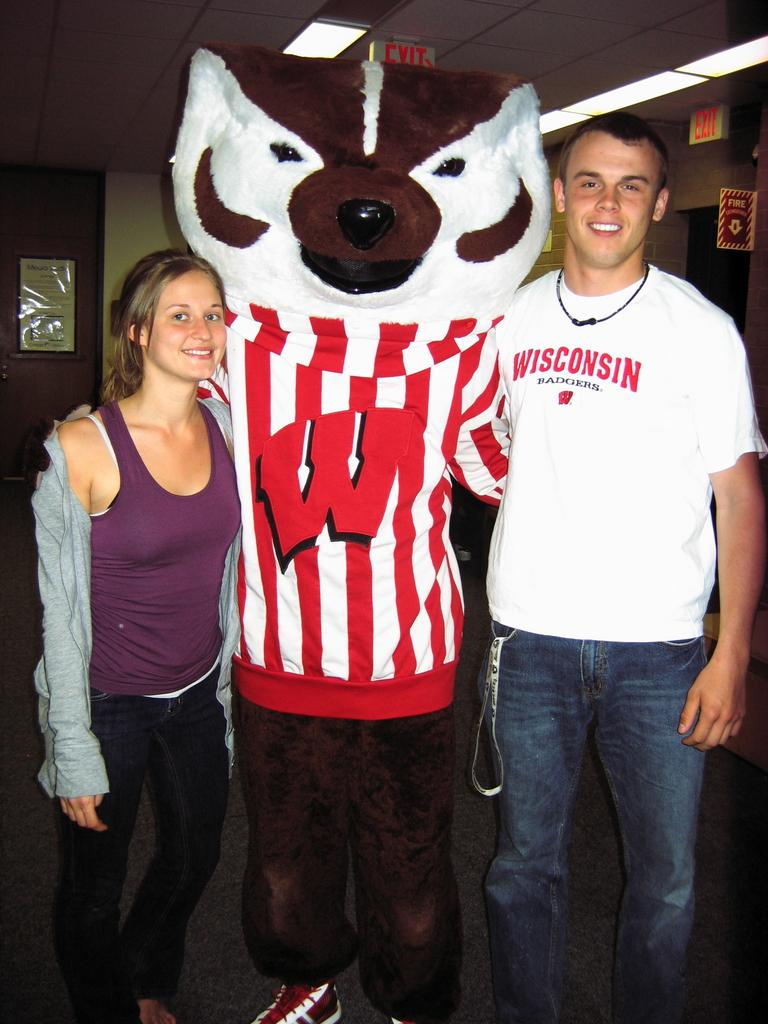<image>
Present a compact description of the photo's key features. a boy wearing a white shirt that says 'wisconsin' on it 